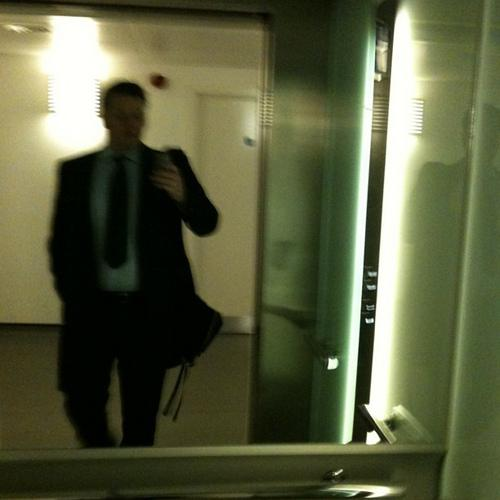Question: what is green?
Choices:
A. Frog.
B. Lighting.
C. Peas.
D. Money.
Answer with the letter. Answer: B Question: who took the picture?
Choices:
A. The neighbor.
B. The landlord.
C. Man in the mirror.
D. The mother-in-law.
Answer with the letter. Answer: C Question: what is white?
Choices:
A. Floor.
B. Wall.
C. Ceiling.
D. Door.
Answer with the letter. Answer: B Question: why is the picture blurry?
Choices:
A. Subject moved.
B. Camera was moving.
C. Too close.
D. Wrong settings.
Answer with the letter. Answer: B Question: what is black?
Choices:
A. Tie.
B. Socks.
C. Suit.
D. Jacket.
Answer with the letter. Answer: C Question: where was the picture taken?
Choices:
A. Bathroom.
B. Kitchen.
C. Dining room.
D. Living room.
Answer with the letter. Answer: A 